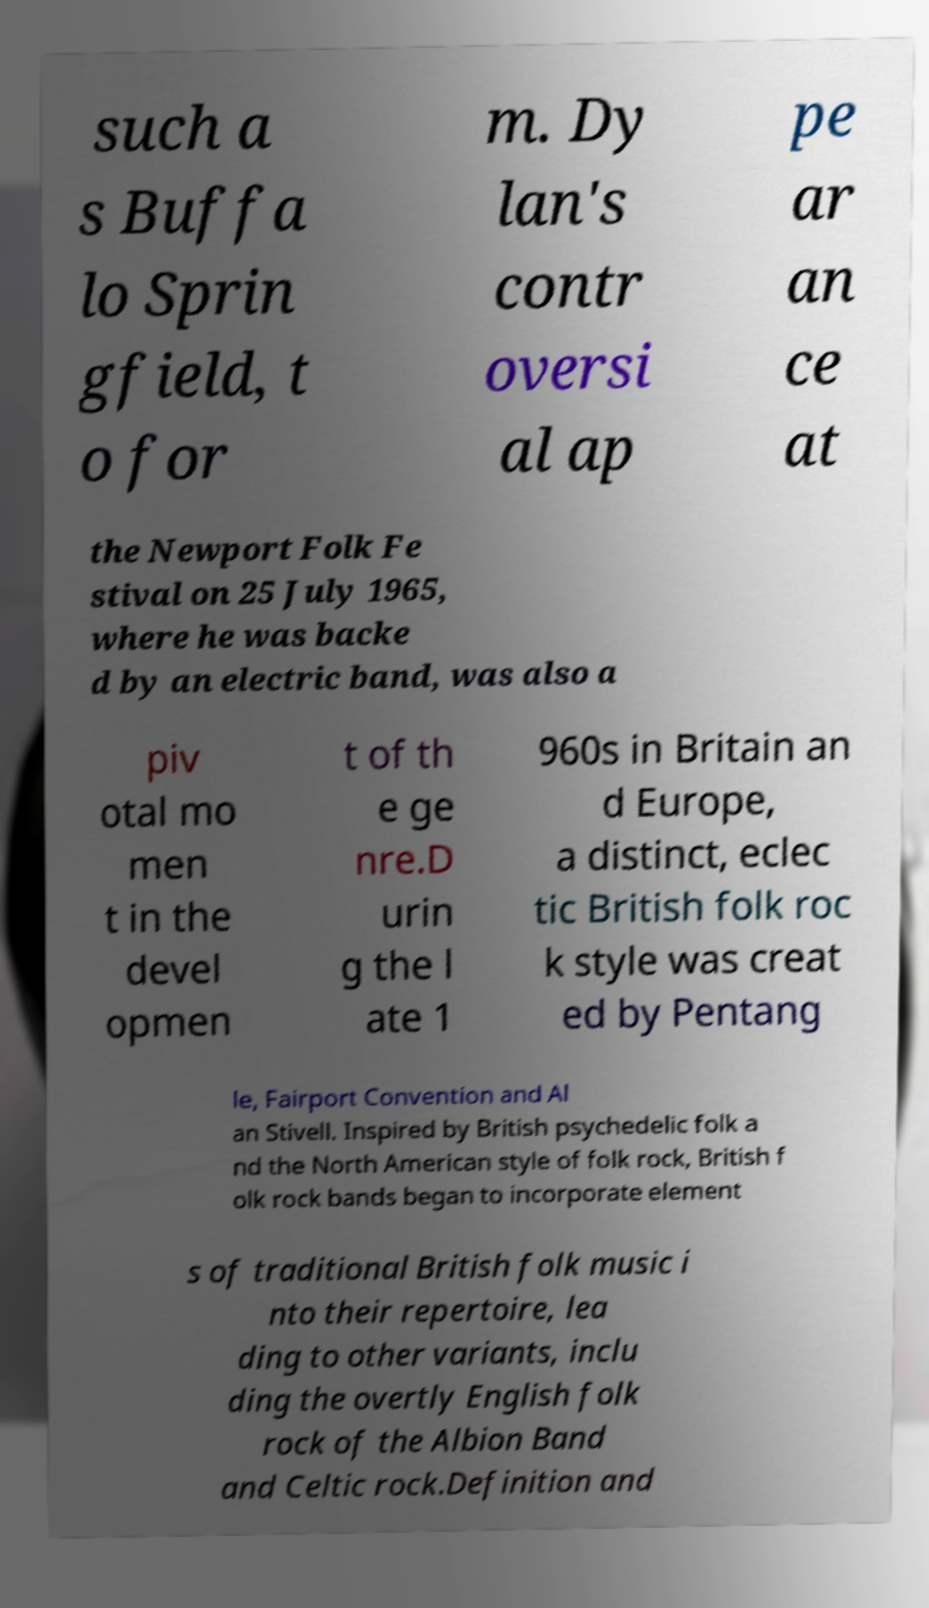For documentation purposes, I need the text within this image transcribed. Could you provide that? such a s Buffa lo Sprin gfield, t o for m. Dy lan's contr oversi al ap pe ar an ce at the Newport Folk Fe stival on 25 July 1965, where he was backe d by an electric band, was also a piv otal mo men t in the devel opmen t of th e ge nre.D urin g the l ate 1 960s in Britain an d Europe, a distinct, eclec tic British folk roc k style was creat ed by Pentang le, Fairport Convention and Al an Stivell. Inspired by British psychedelic folk a nd the North American style of folk rock, British f olk rock bands began to incorporate element s of traditional British folk music i nto their repertoire, lea ding to other variants, inclu ding the overtly English folk rock of the Albion Band and Celtic rock.Definition and 